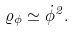Convert formula to latex. <formula><loc_0><loc_0><loc_500><loc_500>\varrho _ { \phi } \simeq \dot { \phi } ^ { 2 } .</formula> 